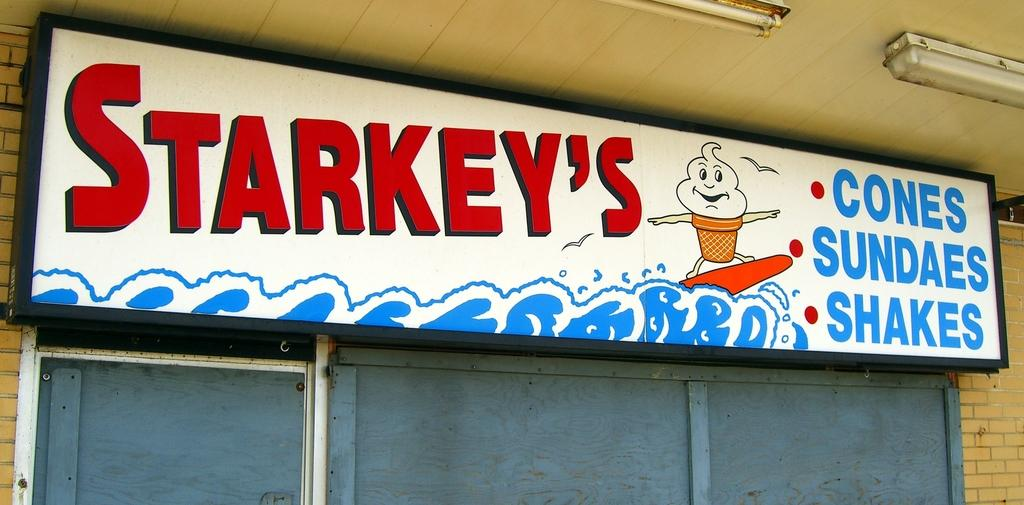<image>
Write a terse but informative summary of the picture. A sign for a restaurant named Starkey's with an ice cream surfing on a wave 